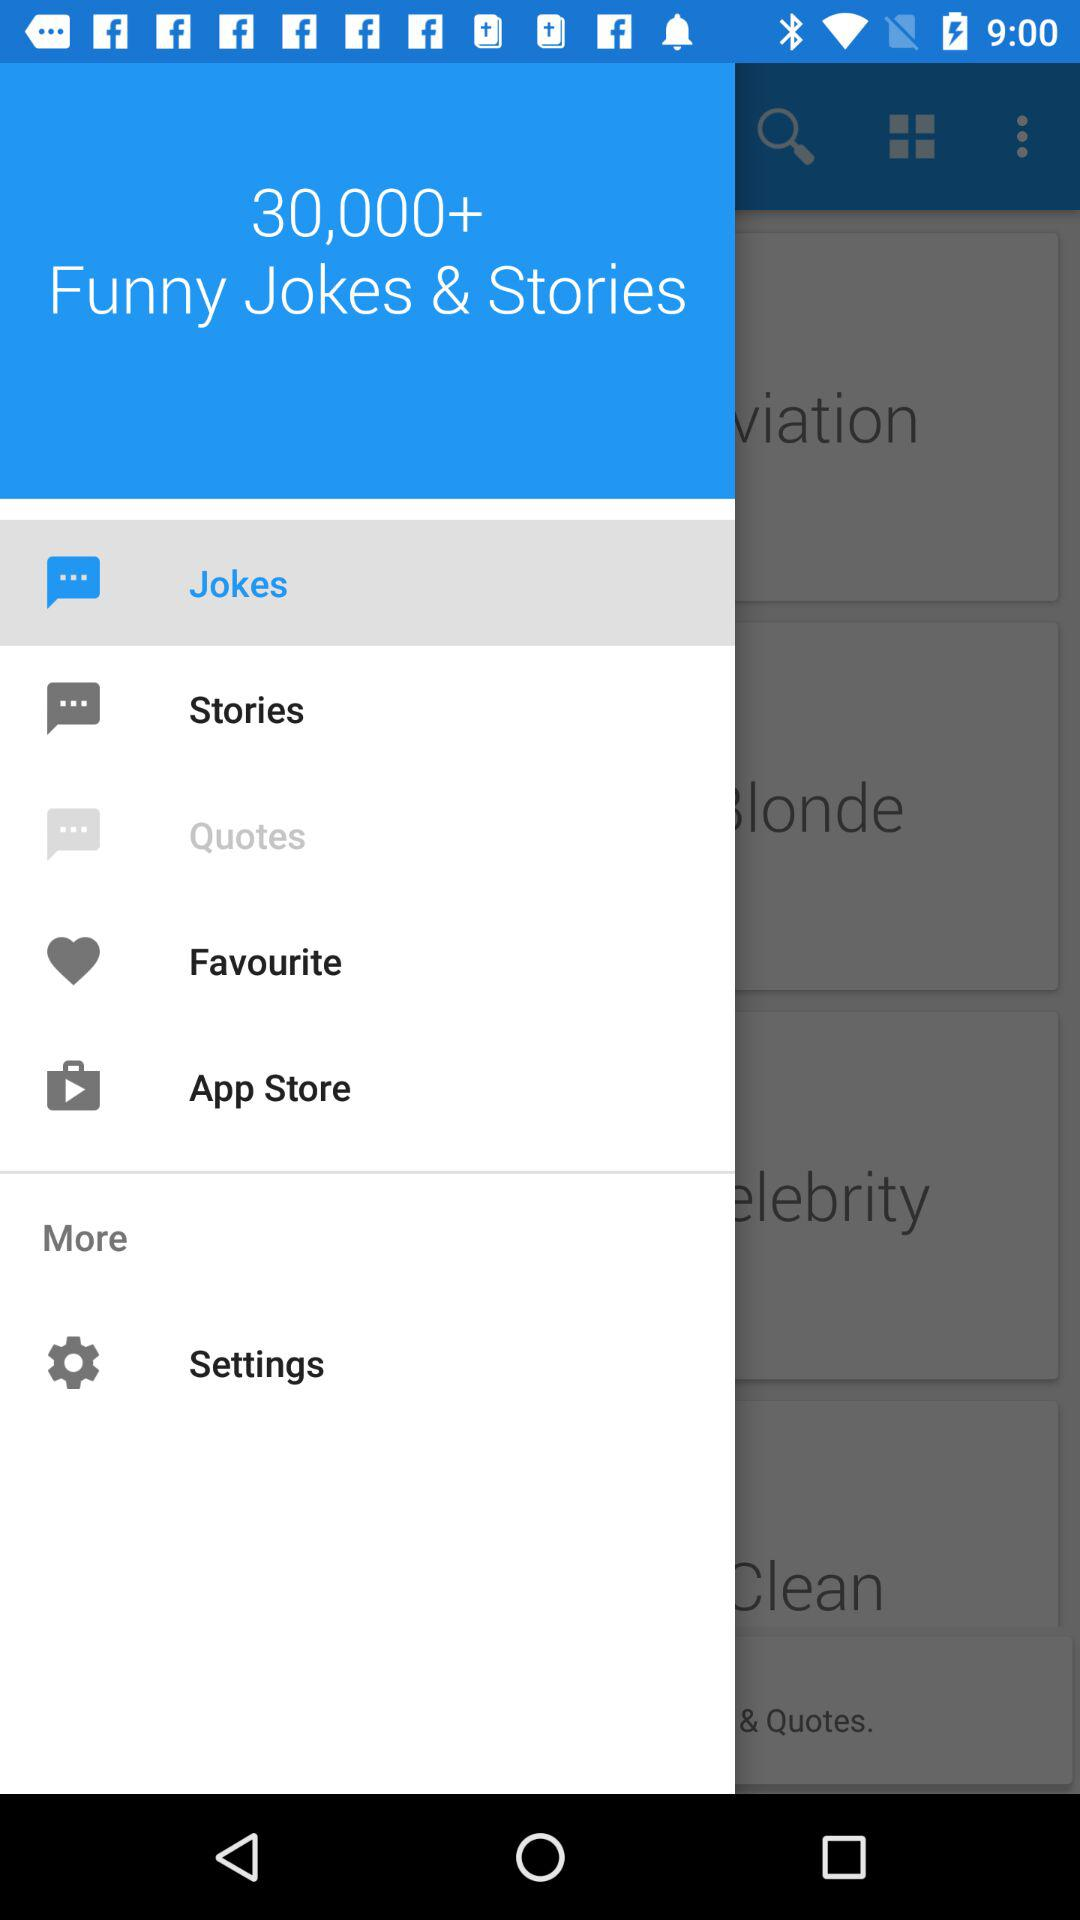Which joke category is selected?
When the provided information is insufficient, respond with <no answer>. <no answer> 